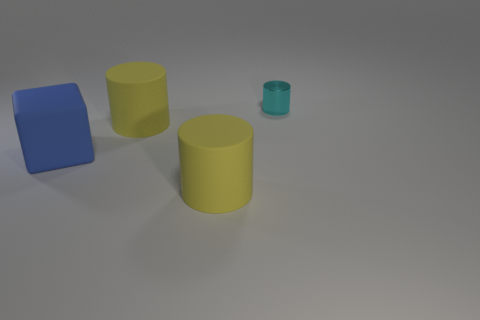Add 1 matte blocks. How many objects exist? 5 Subtract all blocks. How many objects are left? 3 Add 4 large cyan metallic cylinders. How many large cyan metallic cylinders exist? 4 Subtract 0 green spheres. How many objects are left? 4 Subtract all big brown metallic spheres. Subtract all blue things. How many objects are left? 3 Add 2 blue things. How many blue things are left? 3 